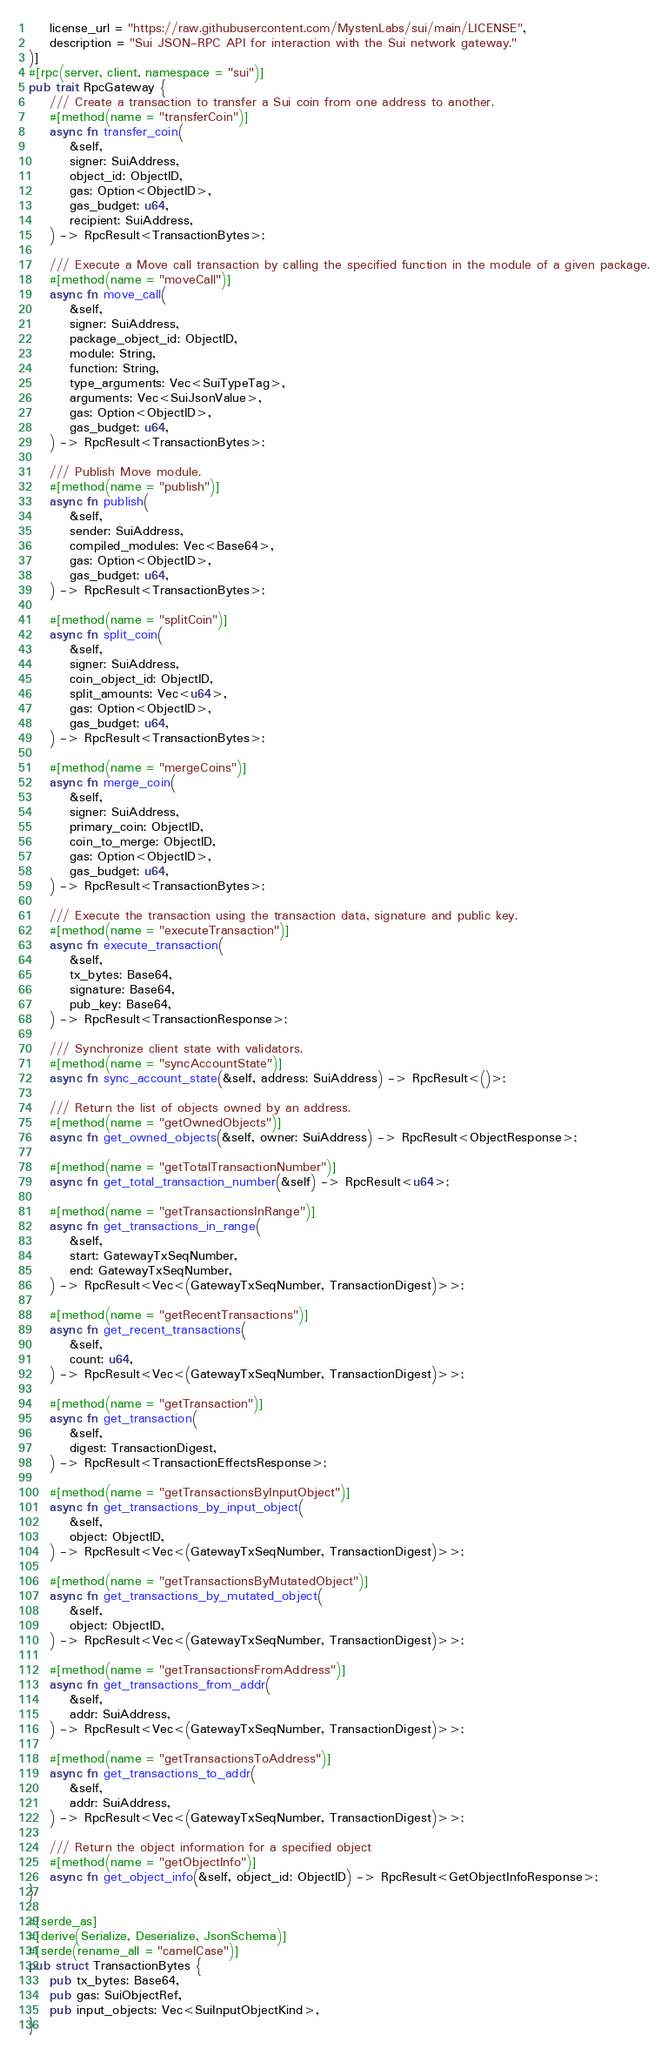Convert code to text. <code><loc_0><loc_0><loc_500><loc_500><_Rust_>    license_url = "https://raw.githubusercontent.com/MystenLabs/sui/main/LICENSE",
    description = "Sui JSON-RPC API for interaction with the Sui network gateway."
)]
#[rpc(server, client, namespace = "sui")]
pub trait RpcGateway {
    /// Create a transaction to transfer a Sui coin from one address to another.
    #[method(name = "transferCoin")]
    async fn transfer_coin(
        &self,
        signer: SuiAddress,
        object_id: ObjectID,
        gas: Option<ObjectID>,
        gas_budget: u64,
        recipient: SuiAddress,
    ) -> RpcResult<TransactionBytes>;

    /// Execute a Move call transaction by calling the specified function in the module of a given package.
    #[method(name = "moveCall")]
    async fn move_call(
        &self,
        signer: SuiAddress,
        package_object_id: ObjectID,
        module: String,
        function: String,
        type_arguments: Vec<SuiTypeTag>,
        arguments: Vec<SuiJsonValue>,
        gas: Option<ObjectID>,
        gas_budget: u64,
    ) -> RpcResult<TransactionBytes>;

    /// Publish Move module.
    #[method(name = "publish")]
    async fn publish(
        &self,
        sender: SuiAddress,
        compiled_modules: Vec<Base64>,
        gas: Option<ObjectID>,
        gas_budget: u64,
    ) -> RpcResult<TransactionBytes>;

    #[method(name = "splitCoin")]
    async fn split_coin(
        &self,
        signer: SuiAddress,
        coin_object_id: ObjectID,
        split_amounts: Vec<u64>,
        gas: Option<ObjectID>,
        gas_budget: u64,
    ) -> RpcResult<TransactionBytes>;

    #[method(name = "mergeCoins")]
    async fn merge_coin(
        &self,
        signer: SuiAddress,
        primary_coin: ObjectID,
        coin_to_merge: ObjectID,
        gas: Option<ObjectID>,
        gas_budget: u64,
    ) -> RpcResult<TransactionBytes>;

    /// Execute the transaction using the transaction data, signature and public key.
    #[method(name = "executeTransaction")]
    async fn execute_transaction(
        &self,
        tx_bytes: Base64,
        signature: Base64,
        pub_key: Base64,
    ) -> RpcResult<TransactionResponse>;

    /// Synchronize client state with validators.
    #[method(name = "syncAccountState")]
    async fn sync_account_state(&self, address: SuiAddress) -> RpcResult<()>;

    /// Return the list of objects owned by an address.
    #[method(name = "getOwnedObjects")]
    async fn get_owned_objects(&self, owner: SuiAddress) -> RpcResult<ObjectResponse>;

    #[method(name = "getTotalTransactionNumber")]
    async fn get_total_transaction_number(&self) -> RpcResult<u64>;

    #[method(name = "getTransactionsInRange")]
    async fn get_transactions_in_range(
        &self,
        start: GatewayTxSeqNumber,
        end: GatewayTxSeqNumber,
    ) -> RpcResult<Vec<(GatewayTxSeqNumber, TransactionDigest)>>;

    #[method(name = "getRecentTransactions")]
    async fn get_recent_transactions(
        &self,
        count: u64,
    ) -> RpcResult<Vec<(GatewayTxSeqNumber, TransactionDigest)>>;

    #[method(name = "getTransaction")]
    async fn get_transaction(
        &self,
        digest: TransactionDigest,
    ) -> RpcResult<TransactionEffectsResponse>;

    #[method(name = "getTransactionsByInputObject")]
    async fn get_transactions_by_input_object(
        &self,
        object: ObjectID,
    ) -> RpcResult<Vec<(GatewayTxSeqNumber, TransactionDigest)>>;

    #[method(name = "getTransactionsByMutatedObject")]
    async fn get_transactions_by_mutated_object(
        &self,
        object: ObjectID,
    ) -> RpcResult<Vec<(GatewayTxSeqNumber, TransactionDigest)>>;

    #[method(name = "getTransactionsFromAddress")]
    async fn get_transactions_from_addr(
        &self,
        addr: SuiAddress,
    ) -> RpcResult<Vec<(GatewayTxSeqNumber, TransactionDigest)>>;

    #[method(name = "getTransactionsToAddress")]
    async fn get_transactions_to_addr(
        &self,
        addr: SuiAddress,
    ) -> RpcResult<Vec<(GatewayTxSeqNumber, TransactionDigest)>>;

    /// Return the object information for a specified object
    #[method(name = "getObjectInfo")]
    async fn get_object_info(&self, object_id: ObjectID) -> RpcResult<GetObjectInfoResponse>;
}

#[serde_as]
#[derive(Serialize, Deserialize, JsonSchema)]
#[serde(rename_all = "camelCase")]
pub struct TransactionBytes {
    pub tx_bytes: Base64,
    pub gas: SuiObjectRef,
    pub input_objects: Vec<SuiInputObjectKind>,
}
</code> 